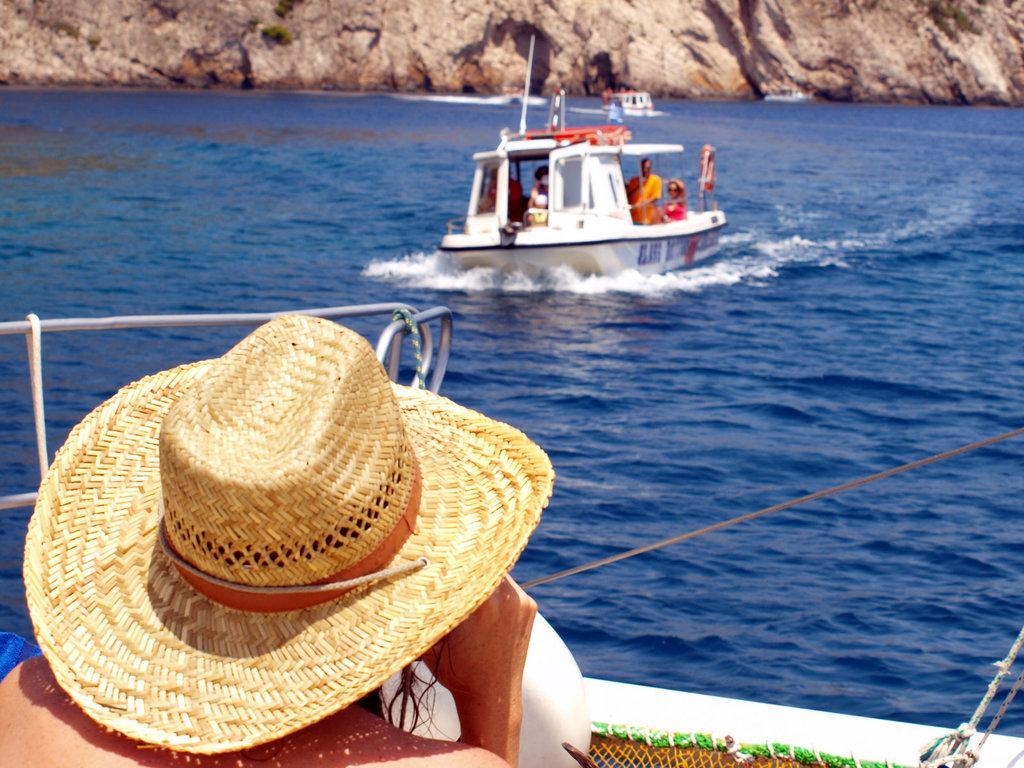How would you summarize this image in a sentence or two? In this image I can see a boat in white color and the boat is in the water. I can also see group of people sitting in the boat, in front I can see a cap in cream color. Background I can see the rock in brown color. 